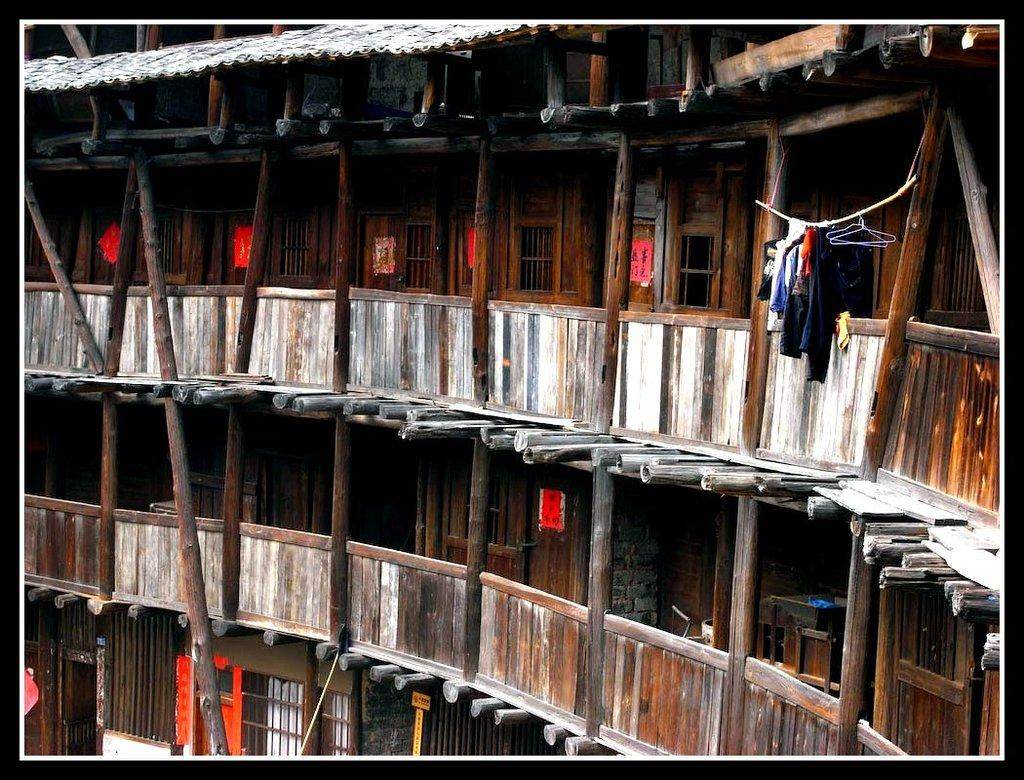What structure is visible in the image? There is a building in the image. What is attached to the beam of the building? There is a rope attached to the beam of the building. What is hanging on the rope? Clothes are hanging on the rope. What is the cause of the rope's good-bye in the image? There is no rope "good-bye" in the image, as the rope is simply hanging and supporting clothes. 